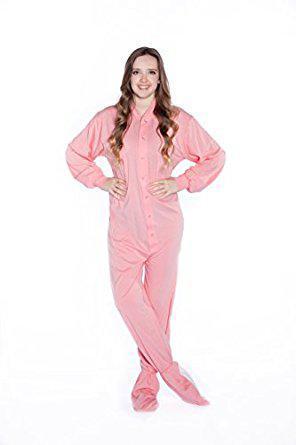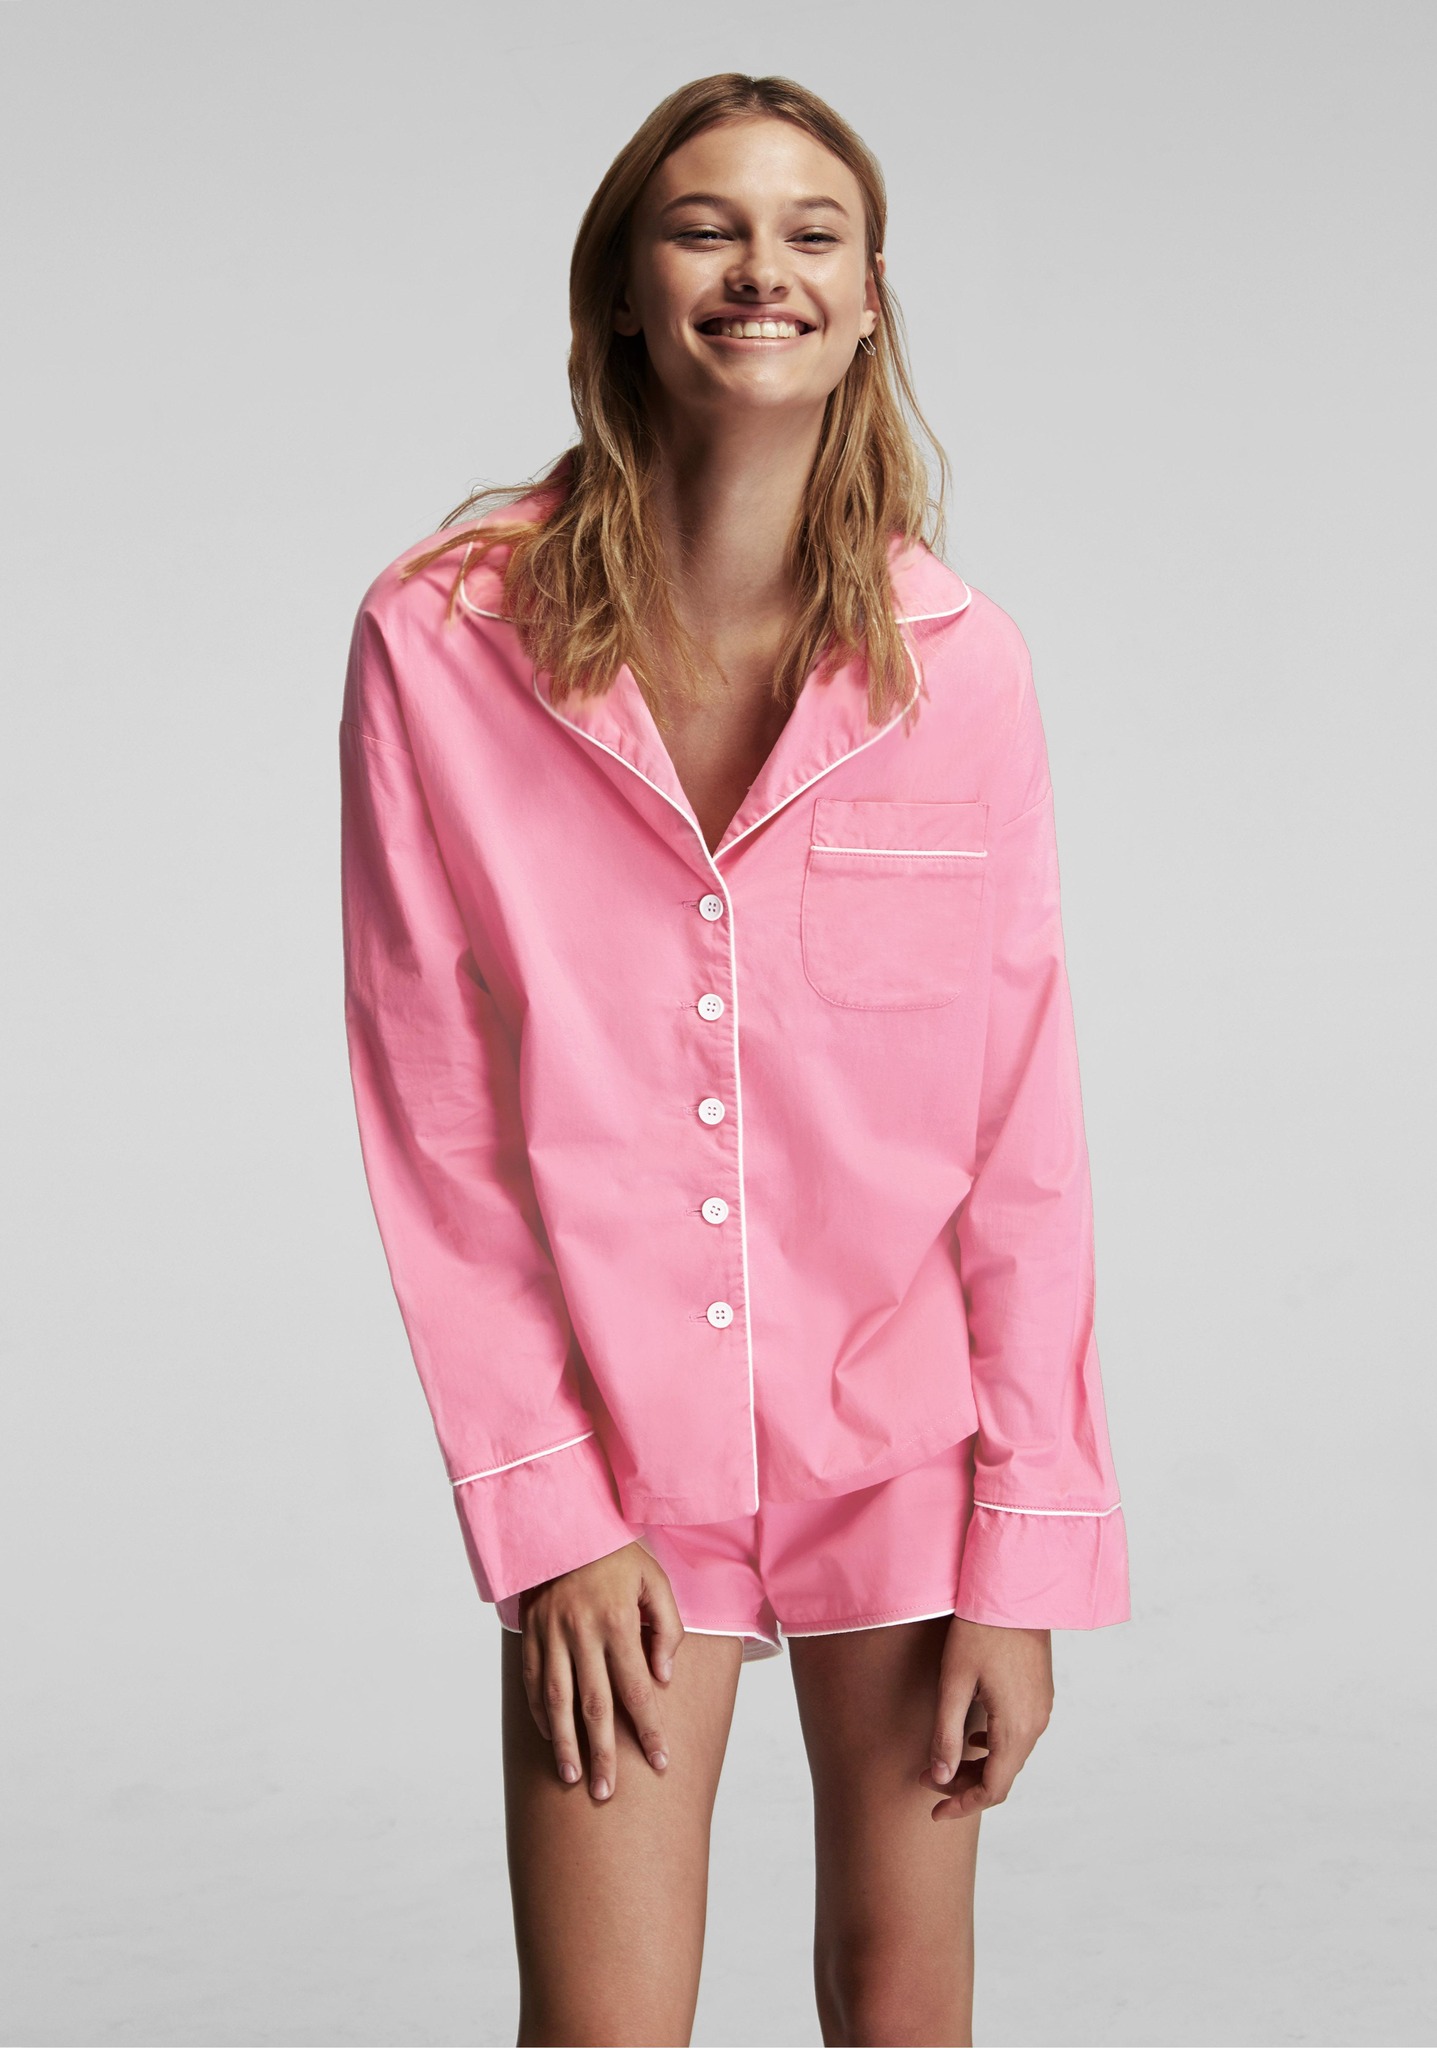The first image is the image on the left, the second image is the image on the right. Assess this claim about the two images: "Exactly one model wears a long sleeved collared button-up top, and exactly one model wears a short sleeve top, but no model wears short shorts.". Correct or not? Answer yes or no. No. The first image is the image on the left, the second image is the image on the right. For the images displayed, is the sentence "A woman is wearing a pajama with short sleeves in one of the images." factually correct? Answer yes or no. No. 